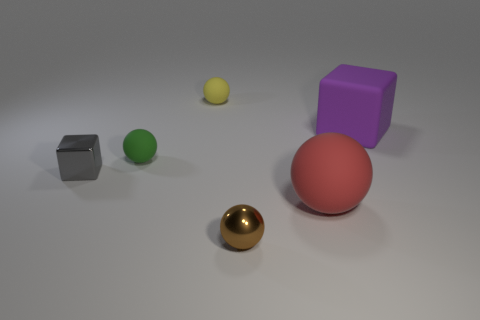What is the shape of the gray metallic thing that is the same size as the brown object?
Provide a short and direct response. Cube. There is a small green matte thing; are there any shiny things to the right of it?
Offer a very short reply. Yes. Is the size of the green ball the same as the red matte ball?
Your answer should be very brief. No. There is a small shiny thing that is behind the red matte object; what is its shape?
Your answer should be very brief. Cube. Are there any gray matte objects that have the same size as the purple matte thing?
Your answer should be compact. No. What is the material of the gray cube that is the same size as the green matte sphere?
Ensure brevity in your answer.  Metal. What is the size of the rubber object in front of the gray cube?
Provide a succinct answer. Large. What is the size of the red sphere?
Offer a very short reply. Large. There is a green rubber thing; is it the same size as the cube that is left of the big red thing?
Provide a succinct answer. Yes. The shiny thing on the left side of the small metallic object that is in front of the small shiny cube is what color?
Make the answer very short. Gray. 